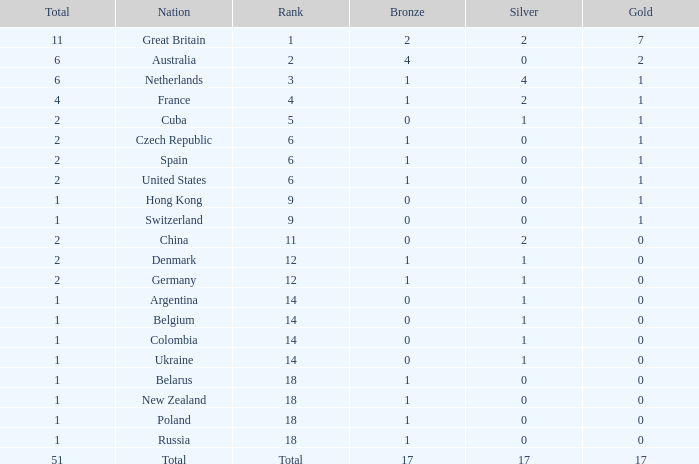Tell me the lowest gold for rank of 6 and total less than 2 None. 